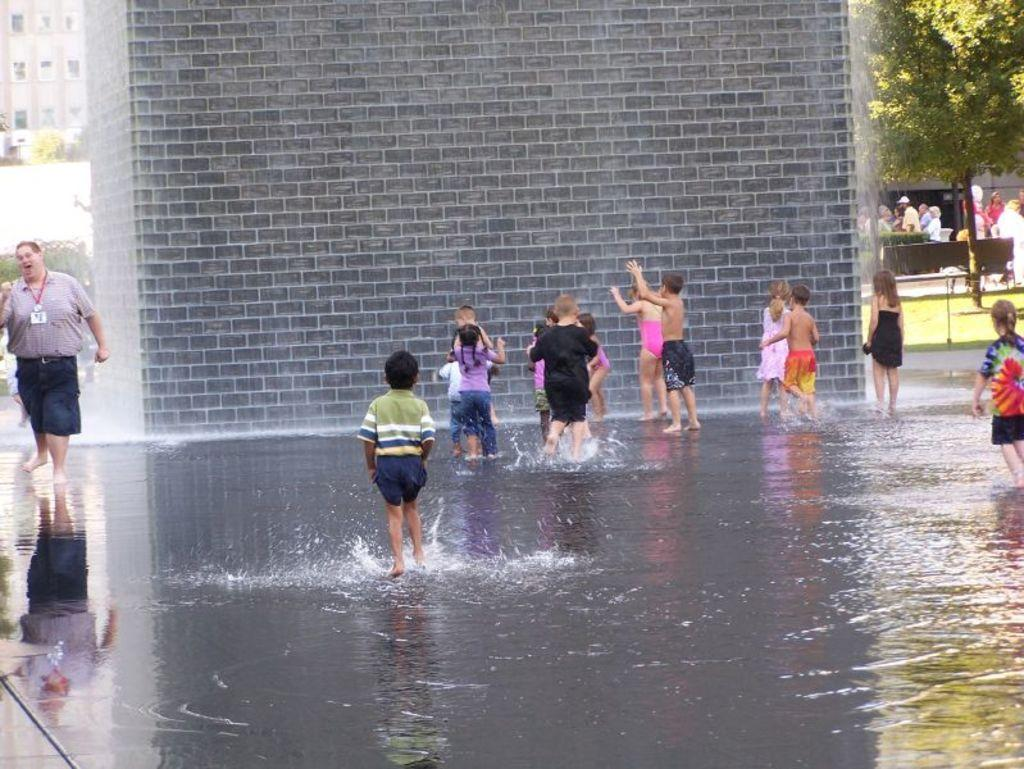What are the kids doing in the image? The kids are standing in the water. What is in front of the kids? There is a wall in front of the kids. Can you describe the person in the image? There is a person standing in the left corner of the image. What can be seen in the background of the image? There is a building and trees in the background. What scent is being emitted by the trees in the image? There is no information about the scent of the trees in the image, as we are only given visual information. 